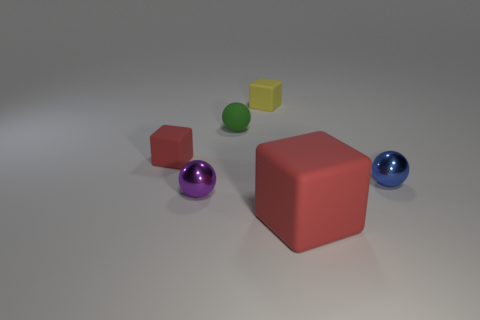Add 1 green objects. How many objects exist? 7 Subtract all tiny yellow objects. Subtract all yellow things. How many objects are left? 4 Add 6 blue objects. How many blue objects are left? 7 Add 4 tiny cylinders. How many tiny cylinders exist? 4 Subtract 0 yellow spheres. How many objects are left? 6 